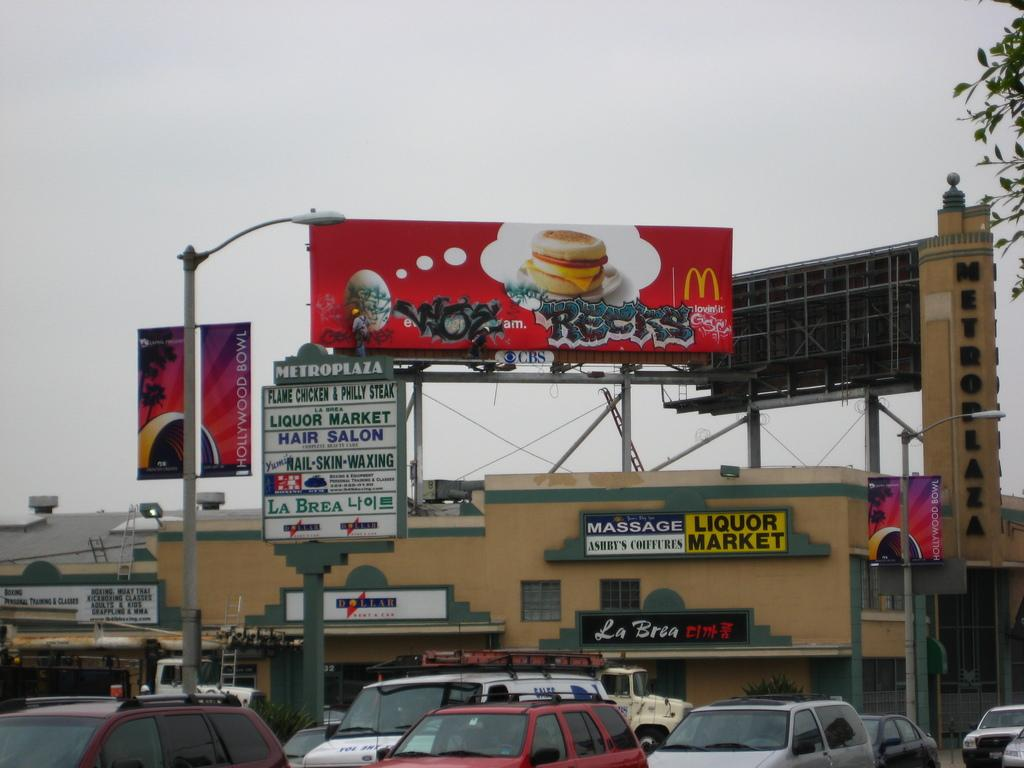<image>
Provide a brief description of the given image. a plaza with a red mcdonald's billboard overhead. 